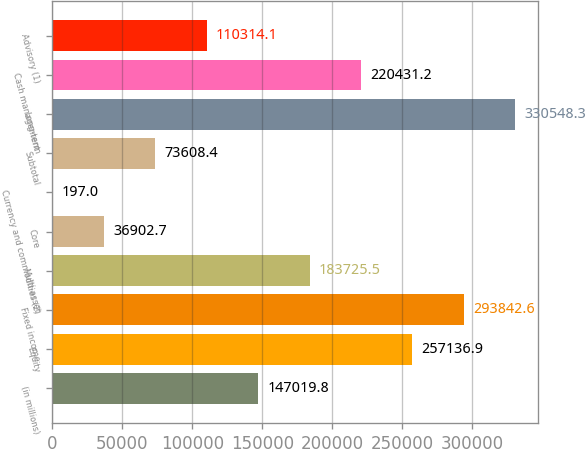<chart> <loc_0><loc_0><loc_500><loc_500><bar_chart><fcel>(in millions)<fcel>Equity<fcel>Fixed income<fcel>Multi-asset<fcel>Core<fcel>Currency and commodities (2)<fcel>Subtotal<fcel>Long-term<fcel>Cash management<fcel>Advisory (1)<nl><fcel>147020<fcel>257137<fcel>293843<fcel>183726<fcel>36902.7<fcel>197<fcel>73608.4<fcel>330548<fcel>220431<fcel>110314<nl></chart> 